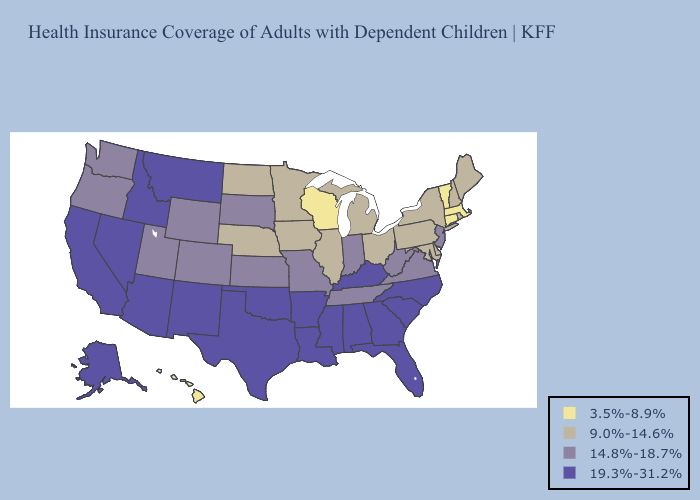Name the states that have a value in the range 14.8%-18.7%?
Keep it brief. Colorado, Indiana, Kansas, Missouri, New Jersey, Oregon, South Dakota, Tennessee, Utah, Virginia, Washington, West Virginia, Wyoming. Does Virginia have a higher value than Kansas?
Be succinct. No. What is the lowest value in the South?
Quick response, please. 9.0%-14.6%. What is the lowest value in the USA?
Concise answer only. 3.5%-8.9%. What is the lowest value in the USA?
Short answer required. 3.5%-8.9%. Among the states that border Ohio , does Kentucky have the lowest value?
Keep it brief. No. Among the states that border Connecticut , which have the lowest value?
Keep it brief. Massachusetts. Name the states that have a value in the range 19.3%-31.2%?
Answer briefly. Alabama, Alaska, Arizona, Arkansas, California, Florida, Georgia, Idaho, Kentucky, Louisiana, Mississippi, Montana, Nevada, New Mexico, North Carolina, Oklahoma, South Carolina, Texas. What is the lowest value in the USA?
Write a very short answer. 3.5%-8.9%. How many symbols are there in the legend?
Concise answer only. 4. Name the states that have a value in the range 9.0%-14.6%?
Give a very brief answer. Delaware, Illinois, Iowa, Maine, Maryland, Michigan, Minnesota, Nebraska, New Hampshire, New York, North Dakota, Ohio, Pennsylvania, Rhode Island. What is the value of Hawaii?
Quick response, please. 3.5%-8.9%. Name the states that have a value in the range 3.5%-8.9%?
Short answer required. Connecticut, Hawaii, Massachusetts, Vermont, Wisconsin. Does the first symbol in the legend represent the smallest category?
Write a very short answer. Yes. Does Utah have the lowest value in the USA?
Answer briefly. No. 